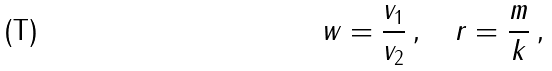Convert formula to latex. <formula><loc_0><loc_0><loc_500><loc_500>w = \frac { v _ { 1 } } { v _ { 2 } } \, , \quad r = \frac { m } { k } \, ,</formula> 